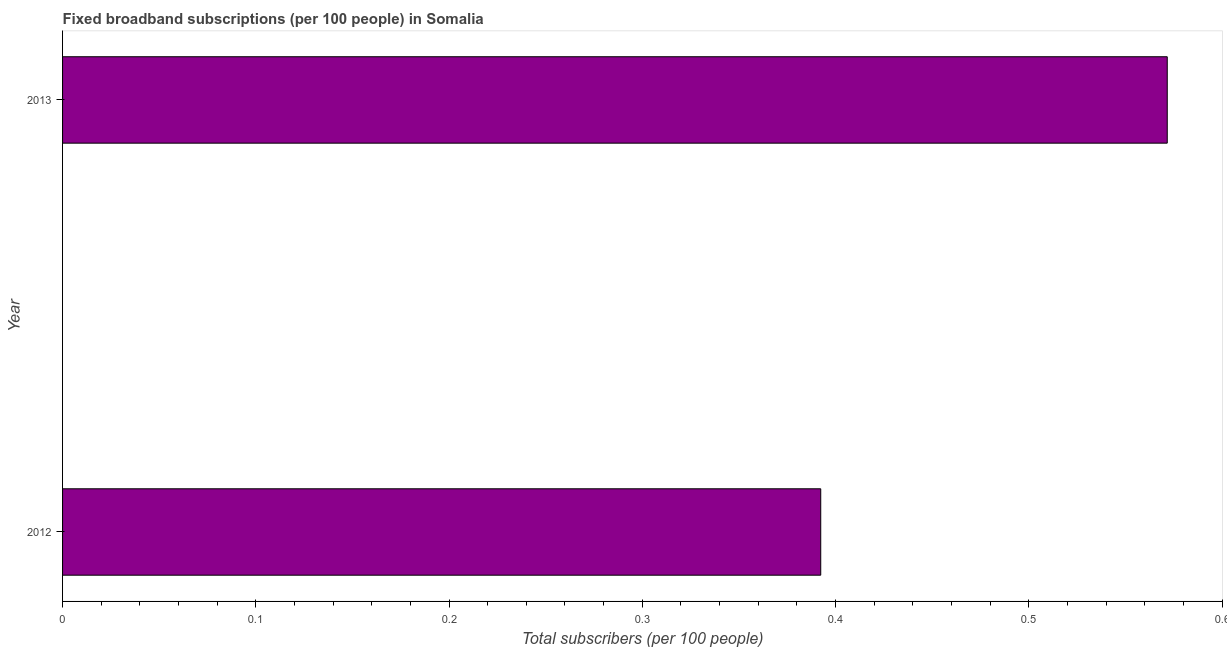Does the graph contain grids?
Your response must be concise. No. What is the title of the graph?
Offer a very short reply. Fixed broadband subscriptions (per 100 people) in Somalia. What is the label or title of the X-axis?
Make the answer very short. Total subscribers (per 100 people). What is the label or title of the Y-axis?
Ensure brevity in your answer.  Year. What is the total number of fixed broadband subscriptions in 2012?
Provide a succinct answer. 0.39. Across all years, what is the maximum total number of fixed broadband subscriptions?
Your response must be concise. 0.57. Across all years, what is the minimum total number of fixed broadband subscriptions?
Your answer should be very brief. 0.39. In which year was the total number of fixed broadband subscriptions minimum?
Provide a short and direct response. 2012. What is the sum of the total number of fixed broadband subscriptions?
Your answer should be very brief. 0.96. What is the difference between the total number of fixed broadband subscriptions in 2012 and 2013?
Provide a short and direct response. -0.18. What is the average total number of fixed broadband subscriptions per year?
Your response must be concise. 0.48. What is the median total number of fixed broadband subscriptions?
Your answer should be compact. 0.48. In how many years, is the total number of fixed broadband subscriptions greater than 0.5 ?
Provide a short and direct response. 1. Do a majority of the years between 2013 and 2012 (inclusive) have total number of fixed broadband subscriptions greater than 0.2 ?
Your response must be concise. No. What is the ratio of the total number of fixed broadband subscriptions in 2012 to that in 2013?
Make the answer very short. 0.69. Is the total number of fixed broadband subscriptions in 2012 less than that in 2013?
Make the answer very short. Yes. In how many years, is the total number of fixed broadband subscriptions greater than the average total number of fixed broadband subscriptions taken over all years?
Make the answer very short. 1. How many bars are there?
Offer a very short reply. 2. Are all the bars in the graph horizontal?
Your response must be concise. Yes. What is the difference between two consecutive major ticks on the X-axis?
Offer a very short reply. 0.1. What is the Total subscribers (per 100 people) of 2012?
Make the answer very short. 0.39. What is the Total subscribers (per 100 people) of 2013?
Your response must be concise. 0.57. What is the difference between the Total subscribers (per 100 people) in 2012 and 2013?
Give a very brief answer. -0.18. What is the ratio of the Total subscribers (per 100 people) in 2012 to that in 2013?
Provide a short and direct response. 0.69. 